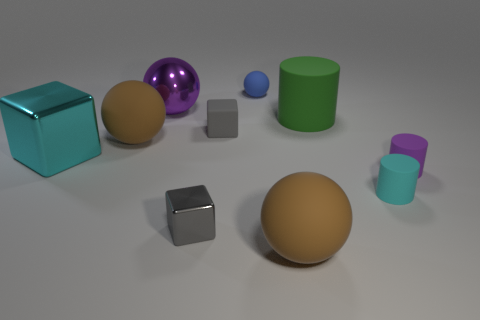Subtract 1 balls. How many balls are left? 3 Subtract all cylinders. How many objects are left? 7 Add 2 tiny cyan rubber cylinders. How many tiny cyan rubber cylinders are left? 3 Add 7 small purple cylinders. How many small purple cylinders exist? 8 Subtract 2 gray blocks. How many objects are left? 8 Subtract all small rubber blocks. Subtract all small objects. How many objects are left? 4 